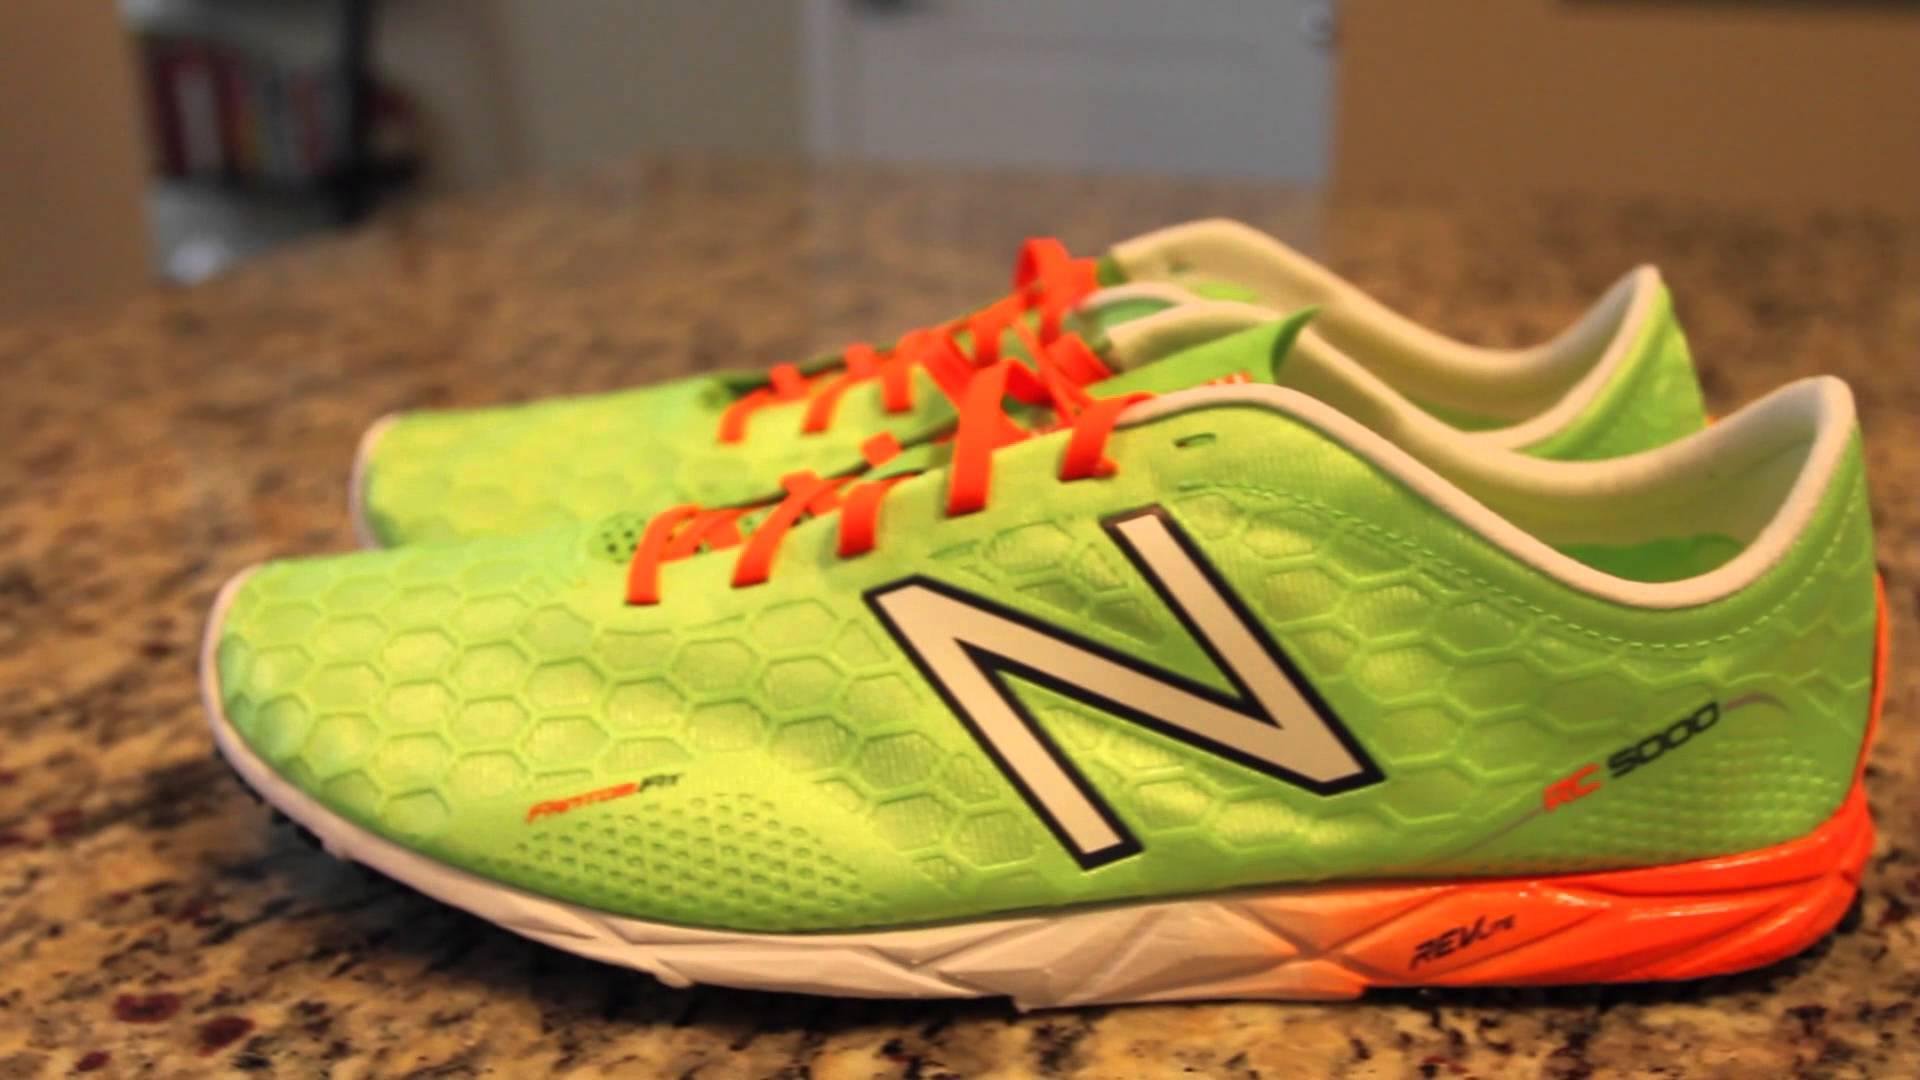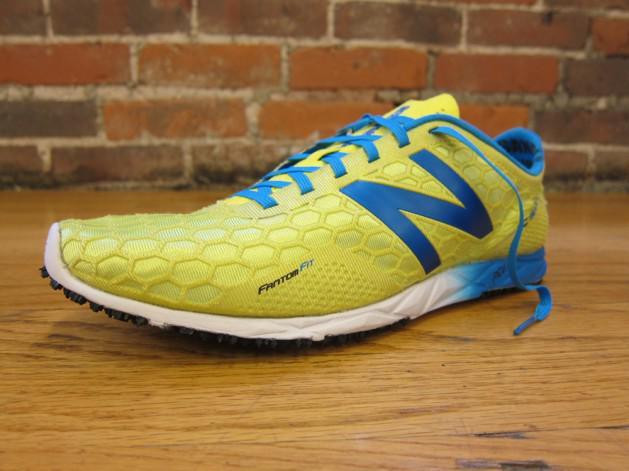The first image is the image on the left, the second image is the image on the right. Given the left and right images, does the statement "The left image shows a pair of sneakers with one of the sneakers resting partially atop the other" hold true? Answer yes or no. No. The first image is the image on the left, the second image is the image on the right. Assess this claim about the two images: "There is exactly three tennis shoes.". Correct or not? Answer yes or no. Yes. 